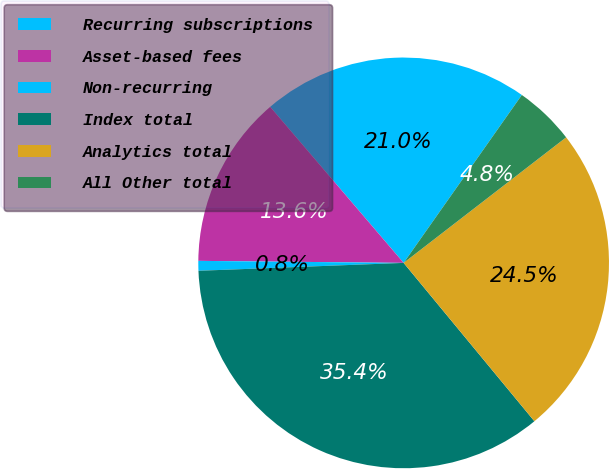<chart> <loc_0><loc_0><loc_500><loc_500><pie_chart><fcel>Recurring subscriptions<fcel>Asset-based fees<fcel>Non-recurring<fcel>Index total<fcel>Analytics total<fcel>All Other total<nl><fcel>21.02%<fcel>13.58%<fcel>0.77%<fcel>35.37%<fcel>24.48%<fcel>4.77%<nl></chart> 